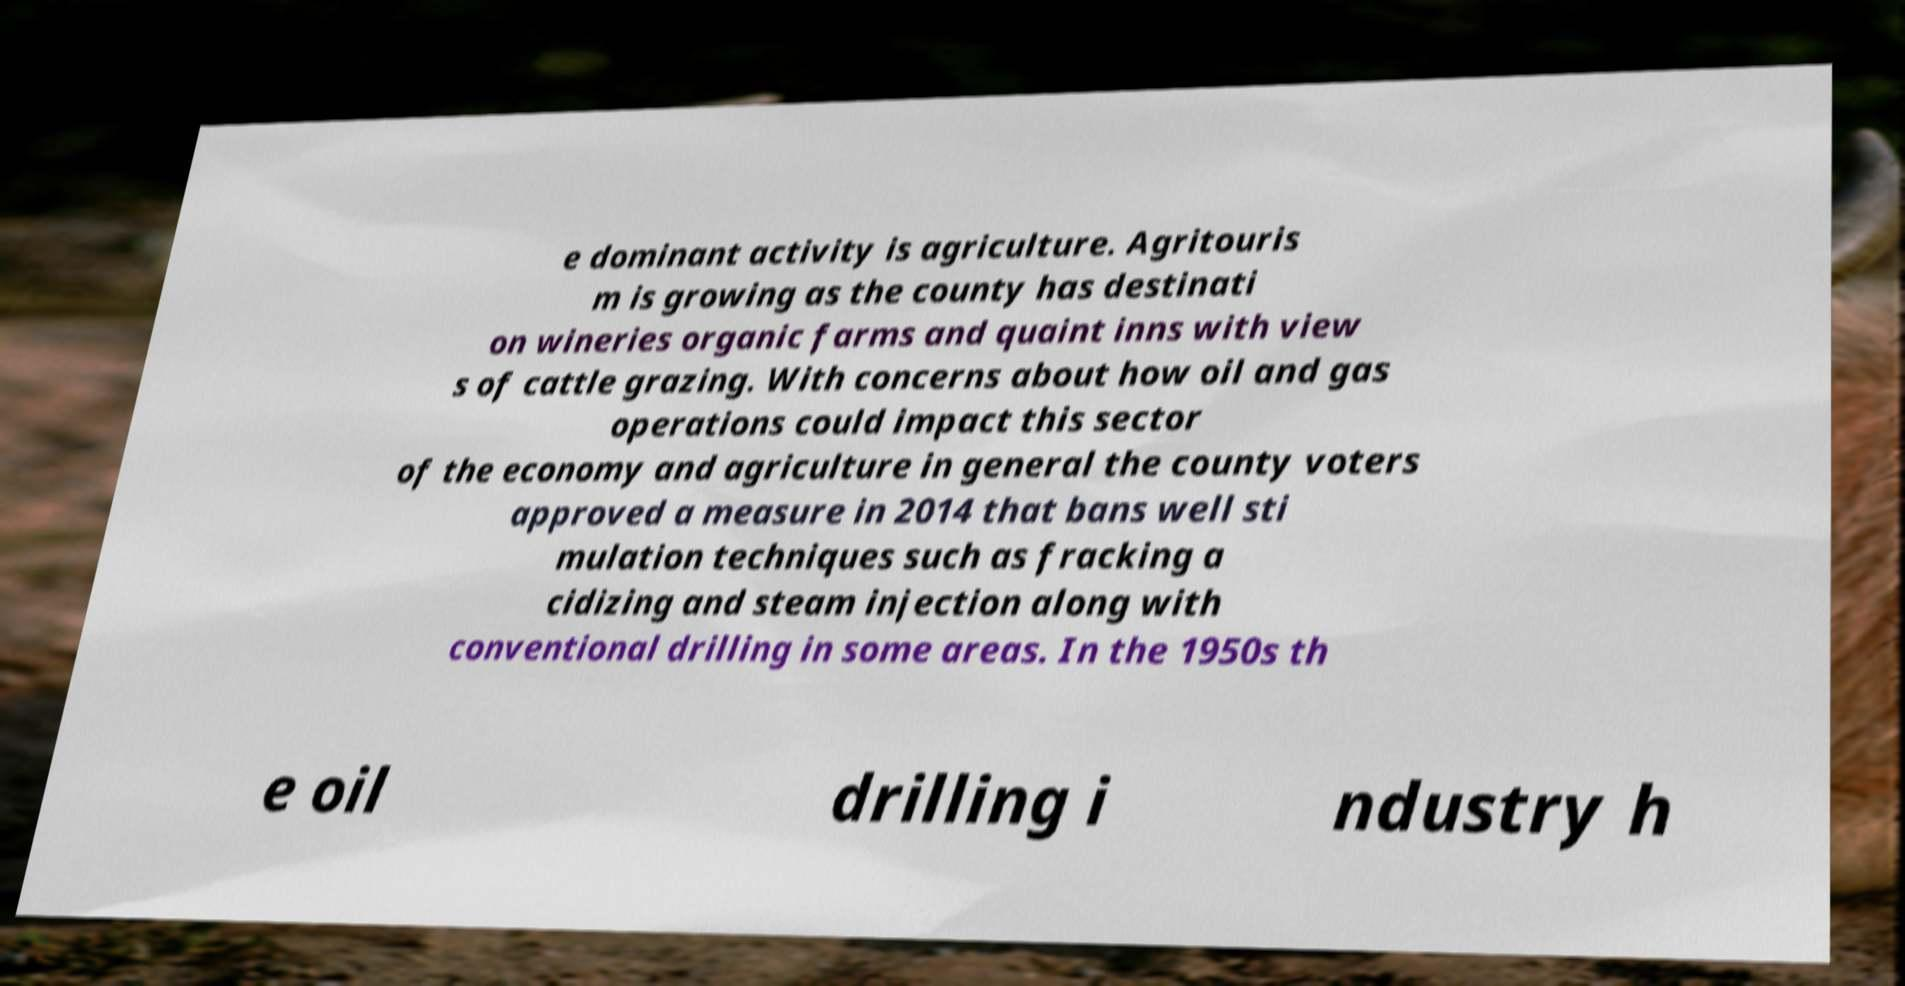Can you read and provide the text displayed in the image?This photo seems to have some interesting text. Can you extract and type it out for me? e dominant activity is agriculture. Agritouris m is growing as the county has destinati on wineries organic farms and quaint inns with view s of cattle grazing. With concerns about how oil and gas operations could impact this sector of the economy and agriculture in general the county voters approved a measure in 2014 that bans well sti mulation techniques such as fracking a cidizing and steam injection along with conventional drilling in some areas. In the 1950s th e oil drilling i ndustry h 